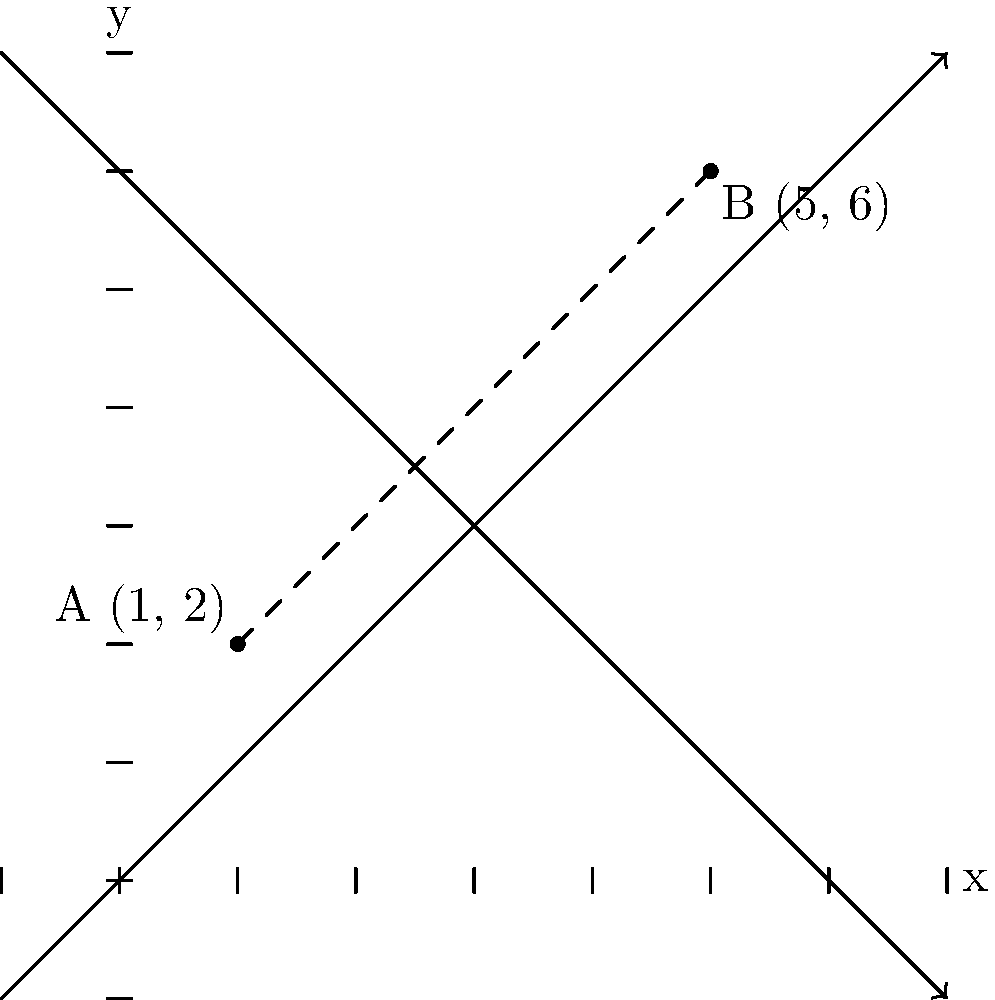As an admin assistant at a job recruitment firm, you need to calculate the distance between two job listing locations. Location A is at coordinates (1, 2) and Location B is at coordinates (5, 6) on a city map represented by a coordinate plane. What is the straight-line distance between these two locations? To find the distance between two points on a coordinate plane, we can use the distance formula, which is derived from the Pythagorean theorem:

$$ d = \sqrt{(x_2 - x_1)^2 + (y_2 - y_1)^2} $$

Where $(x_1, y_1)$ are the coordinates of the first point and $(x_2, y_2)$ are the coordinates of the second point.

Given:
- Point A: $(x_1, y_1) = (1, 2)$
- Point B: $(x_2, y_2) = (5, 6)$

Let's plug these values into the formula:

$$ d = \sqrt{(5 - 1)^2 + (6 - 2)^2} $$

Simplify the expressions inside the parentheses:

$$ d = \sqrt{4^2 + 4^2} $$

Calculate the squares:

$$ d = \sqrt{16 + 16} $$

Add the values under the square root:

$$ d = \sqrt{32} $$

Simplify the square root:

$$ d = 4\sqrt{2} $$

Therefore, the distance between the two job listing locations is $4\sqrt{2}$ units.
Answer: $4\sqrt{2}$ units 